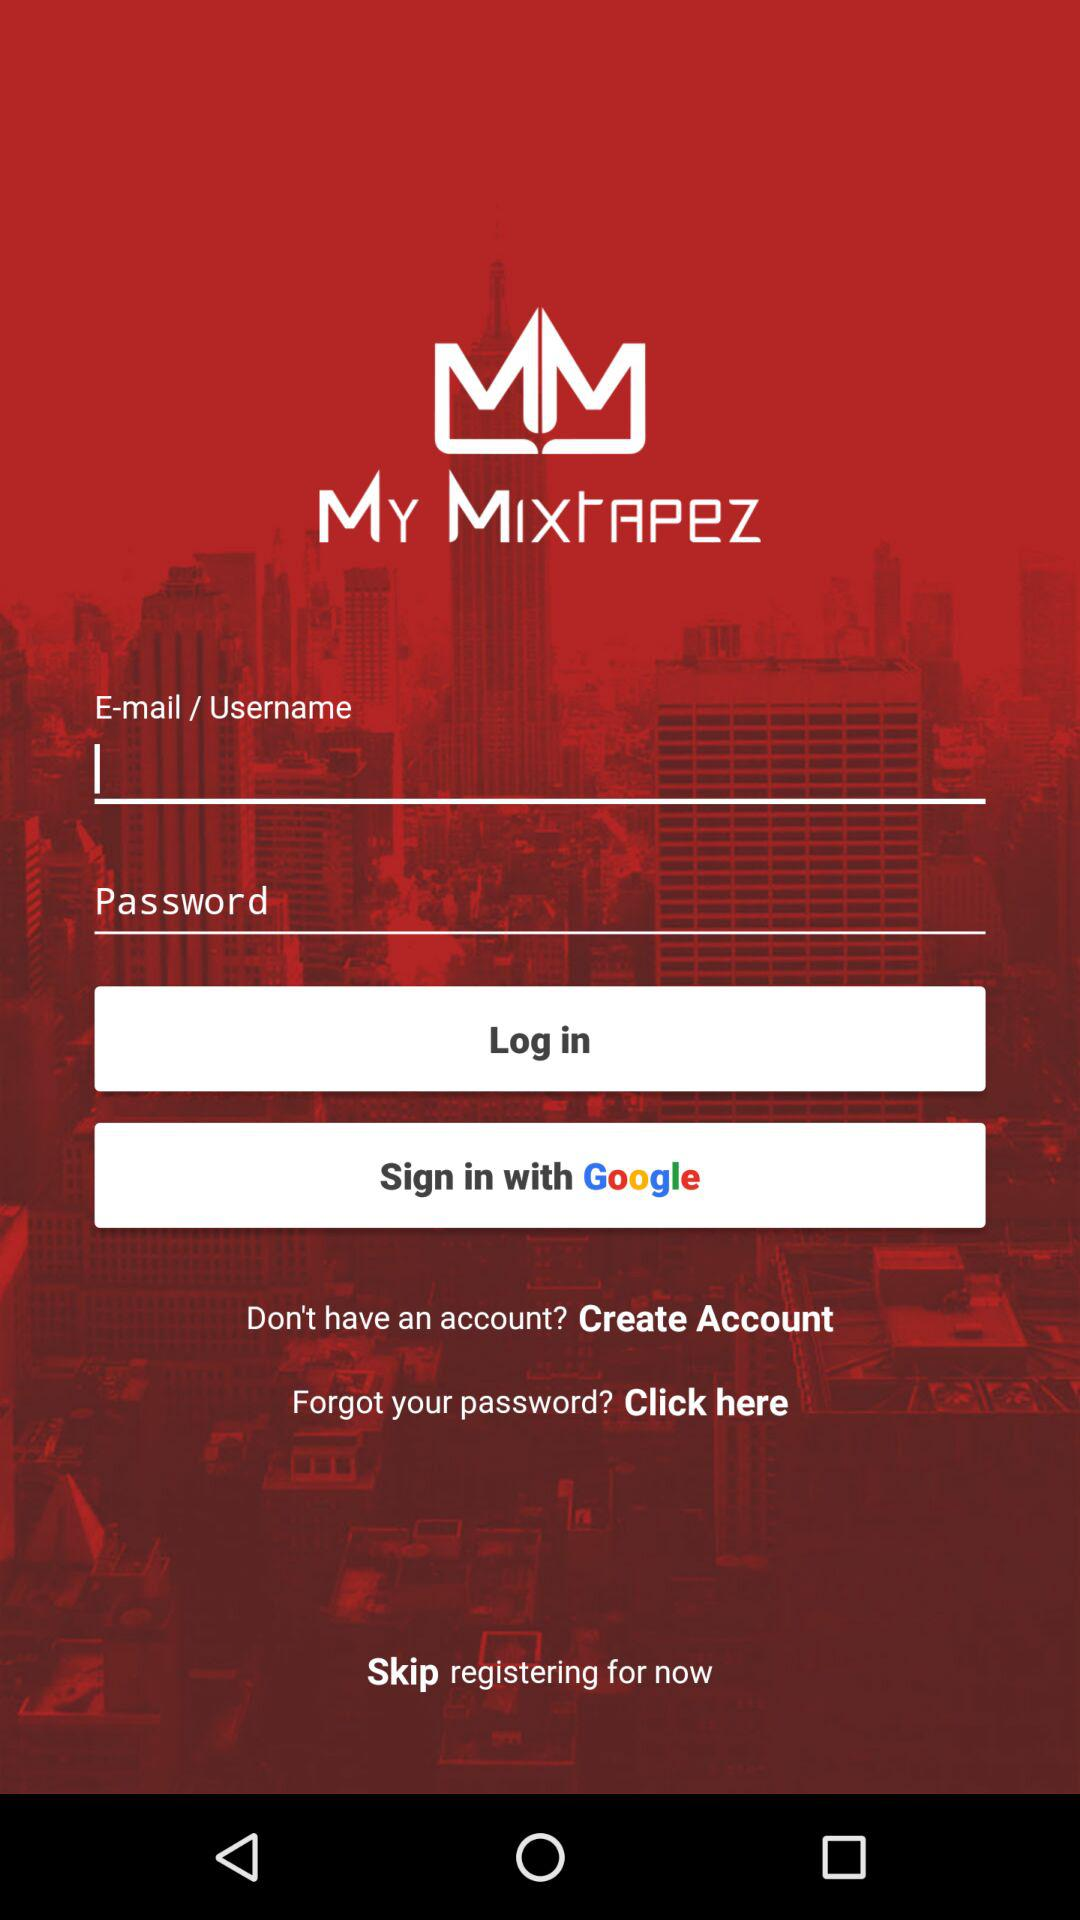What are the different options through which we can sign in? You can sign in through "Google". 